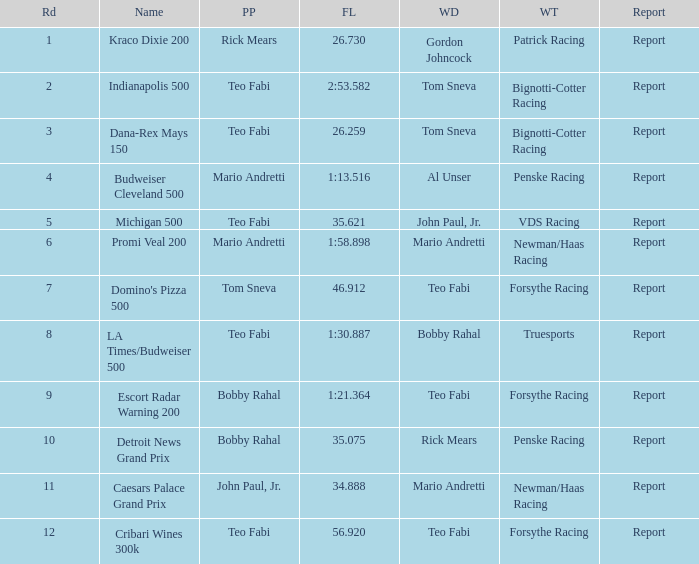Which teams won when Bobby Rahal was their winning driver? Truesports. 